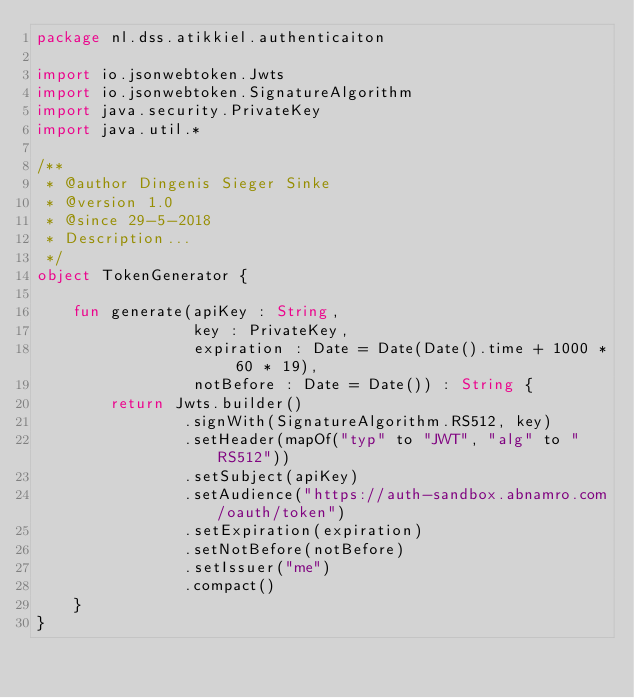<code> <loc_0><loc_0><loc_500><loc_500><_Kotlin_>package nl.dss.atikkiel.authenticaiton

import io.jsonwebtoken.Jwts
import io.jsonwebtoken.SignatureAlgorithm
import java.security.PrivateKey
import java.util.*

/**
 * @author Dingenis Sieger Sinke
 * @version 1.0
 * @since 29-5-2018
 * Description...
 */
object TokenGenerator {

    fun generate(apiKey : String,
                 key : PrivateKey,
                 expiration : Date = Date(Date().time + 1000 * 60 * 19),
                 notBefore : Date = Date()) : String {
        return Jwts.builder()
                .signWith(SignatureAlgorithm.RS512, key)
                .setHeader(mapOf("typ" to "JWT", "alg" to "RS512"))
                .setSubject(apiKey)
                .setAudience("https://auth-sandbox.abnamro.com/oauth/token")
                .setExpiration(expiration)
                .setNotBefore(notBefore)
                .setIssuer("me")
                .compact()
    }
}</code> 